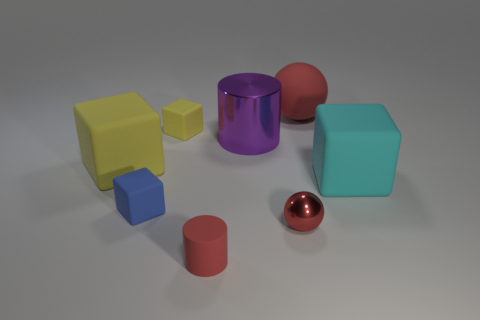Is there a rubber thing that has the same shape as the large shiny thing?
Provide a succinct answer. Yes. What material is the big yellow object?
Your response must be concise. Rubber. Are there any small red metallic spheres in front of the red shiny thing?
Make the answer very short. No. Is the blue matte thing the same shape as the big cyan object?
Provide a succinct answer. Yes. What number of things are either tiny cubes behind the big purple object or gray matte objects?
Your answer should be compact. 1. The rubber sphere has what color?
Your response must be concise. Red. There is a small thing that is right of the tiny red cylinder; what is it made of?
Your response must be concise. Metal. Is the shape of the small yellow object the same as the big matte object left of the large red sphere?
Keep it short and to the point. Yes. Are there more large red matte spheres than yellow matte things?
Ensure brevity in your answer.  No. Is there any other thing of the same color as the small metal ball?
Keep it short and to the point. Yes. 